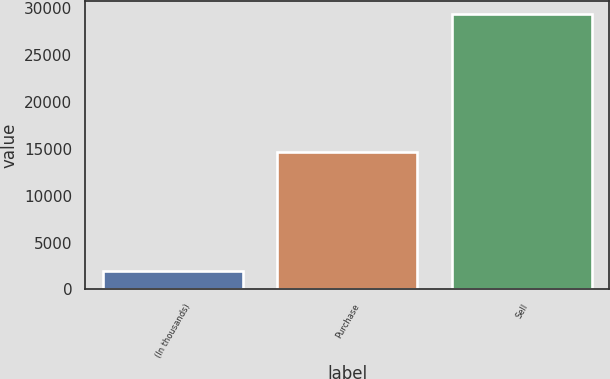Convert chart. <chart><loc_0><loc_0><loc_500><loc_500><bar_chart><fcel>(In thousands)<fcel>Purchase<fcel>Sell<nl><fcel>2012<fcel>14689<fcel>29362<nl></chart> 